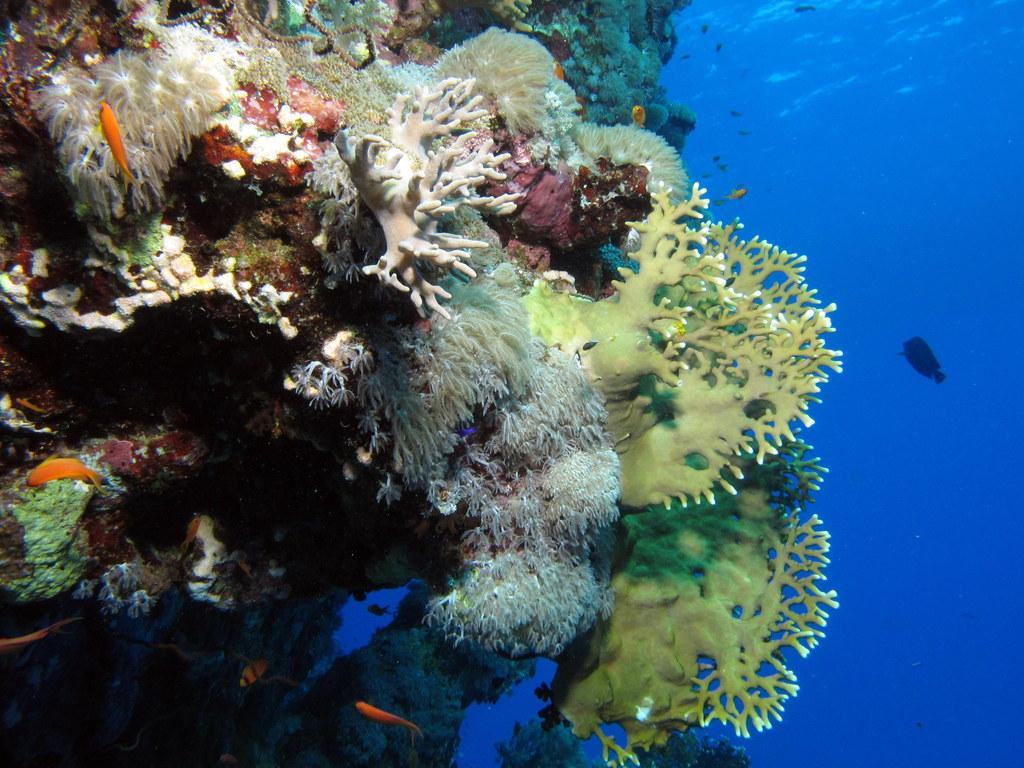What type of animals can be seen in the image? There are fishes in the image. What color is the water in the image? The water is blue in color. What kind of environment is depicted in the image? There is an underwater garden in the image. How would you describe the overall appearance of the image? The image is colorful. What decision does the quince make in the image? There is no quince present in the image, and therefore no decision can be made. 